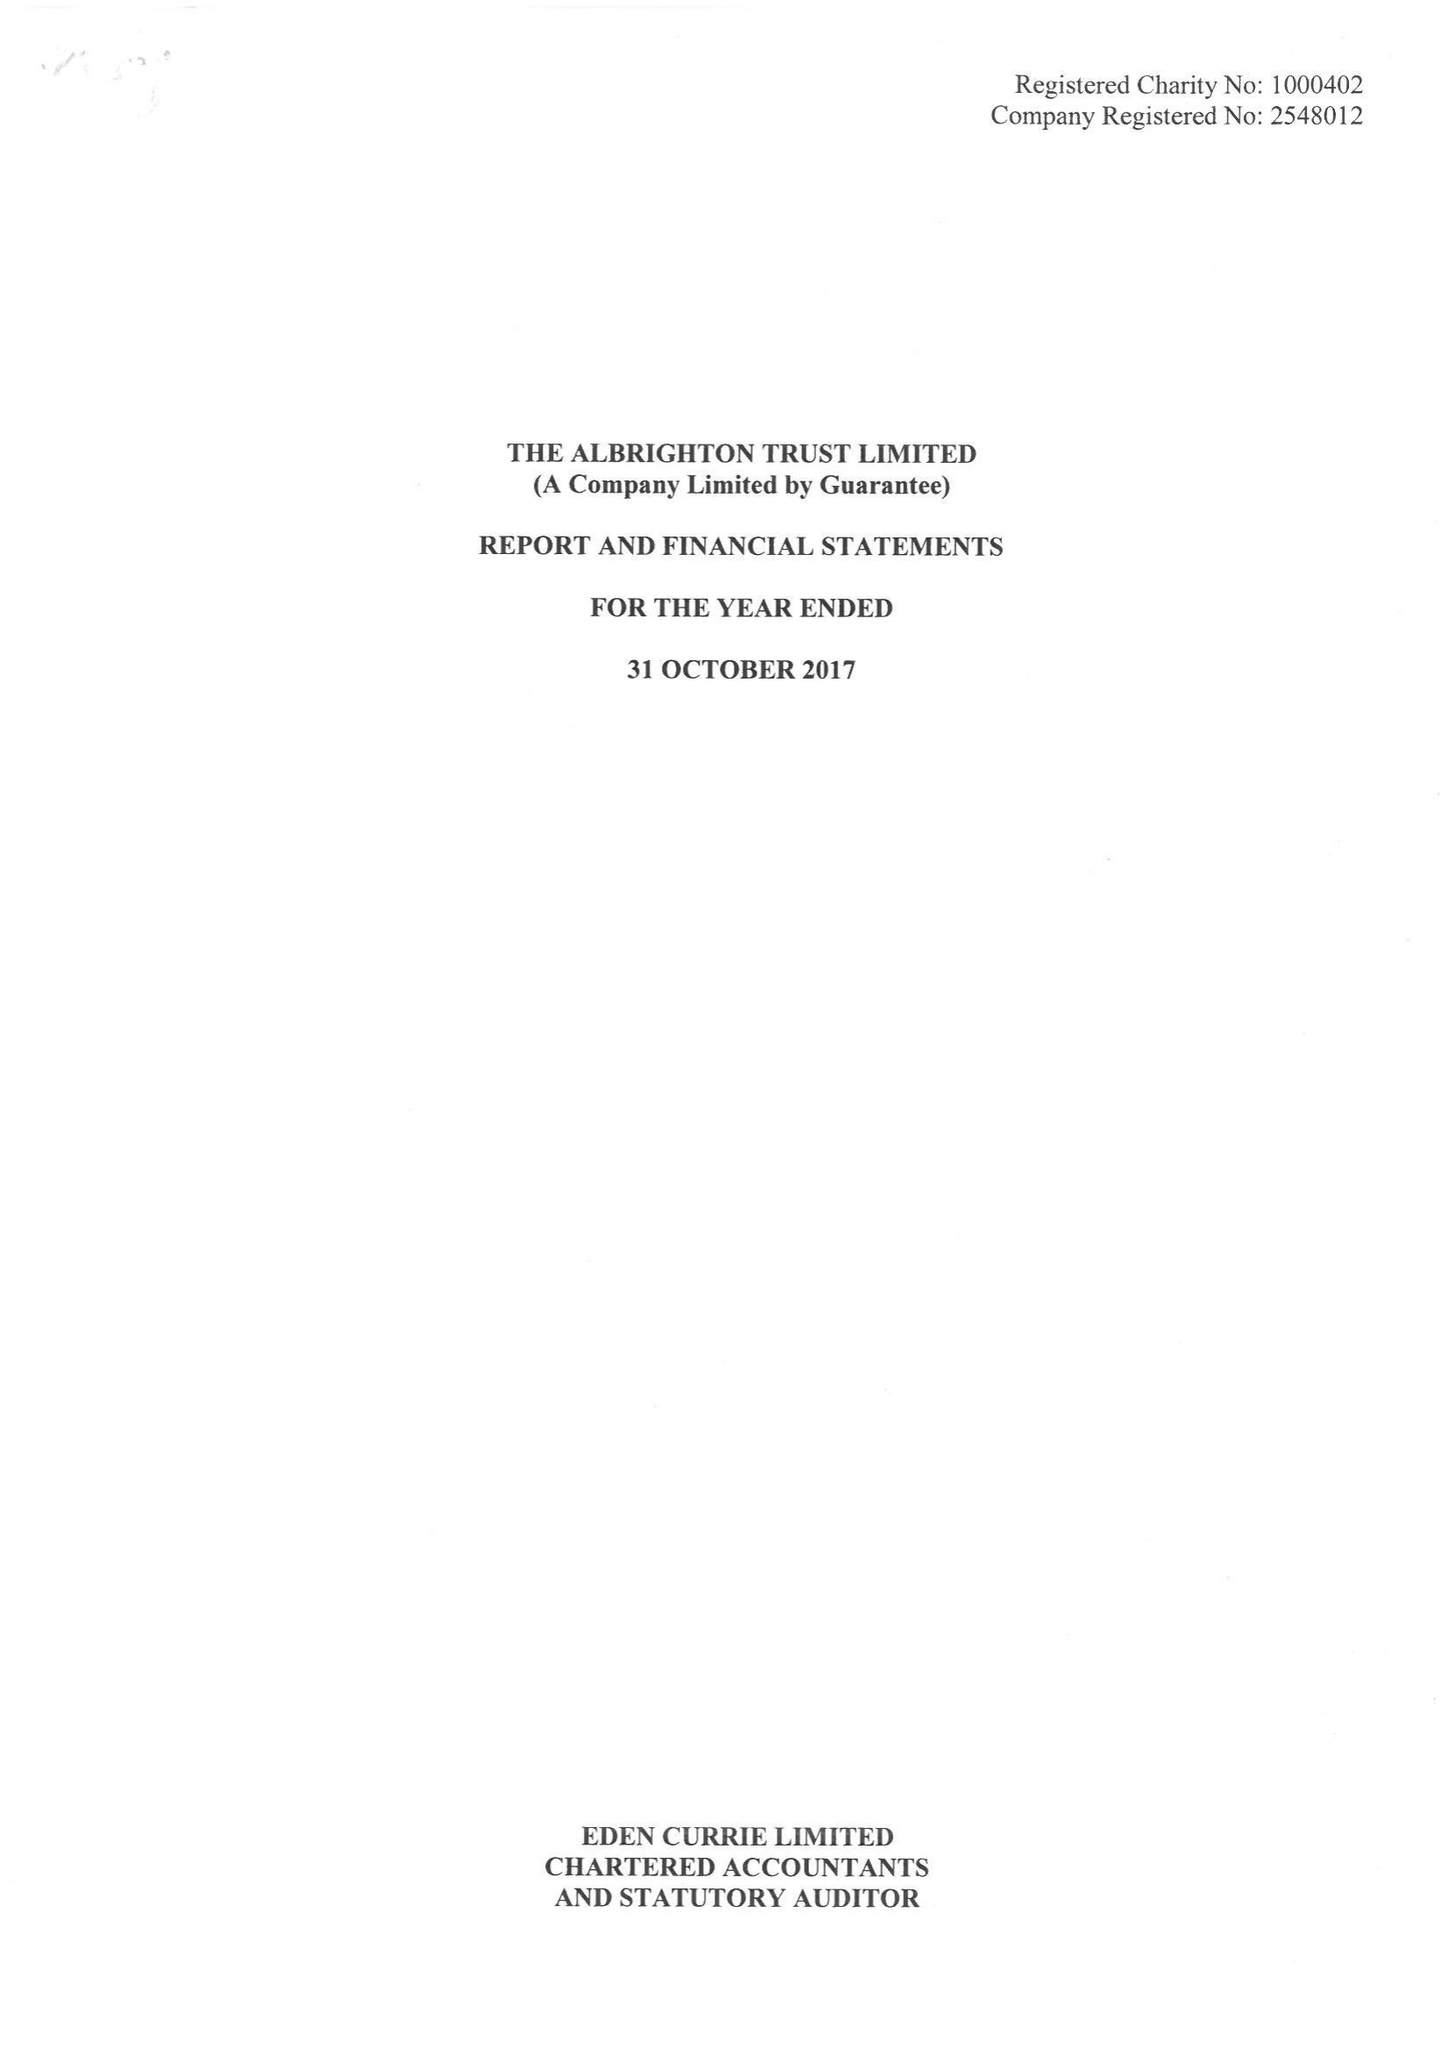What is the value for the income_annually_in_british_pounds?
Answer the question using a single word or phrase. 186699.00 